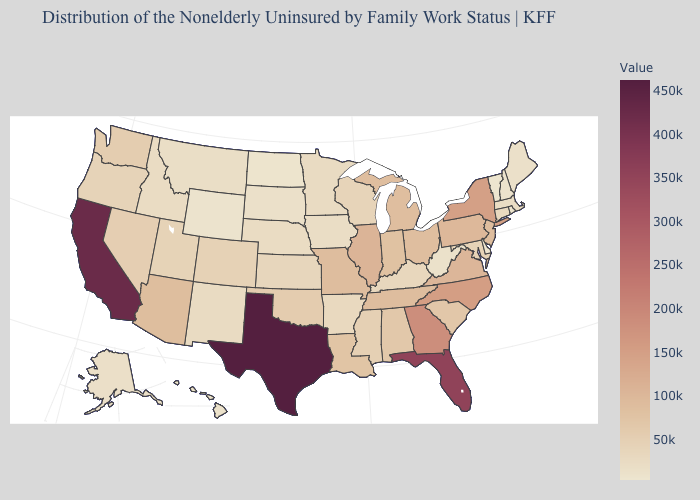Which states have the lowest value in the MidWest?
Keep it brief. North Dakota. Among the states that border New Hampshire , does Massachusetts have the highest value?
Short answer required. Yes. Does Texas have the highest value in the USA?
Write a very short answer. Yes. Which states have the highest value in the USA?
Answer briefly. Texas. 